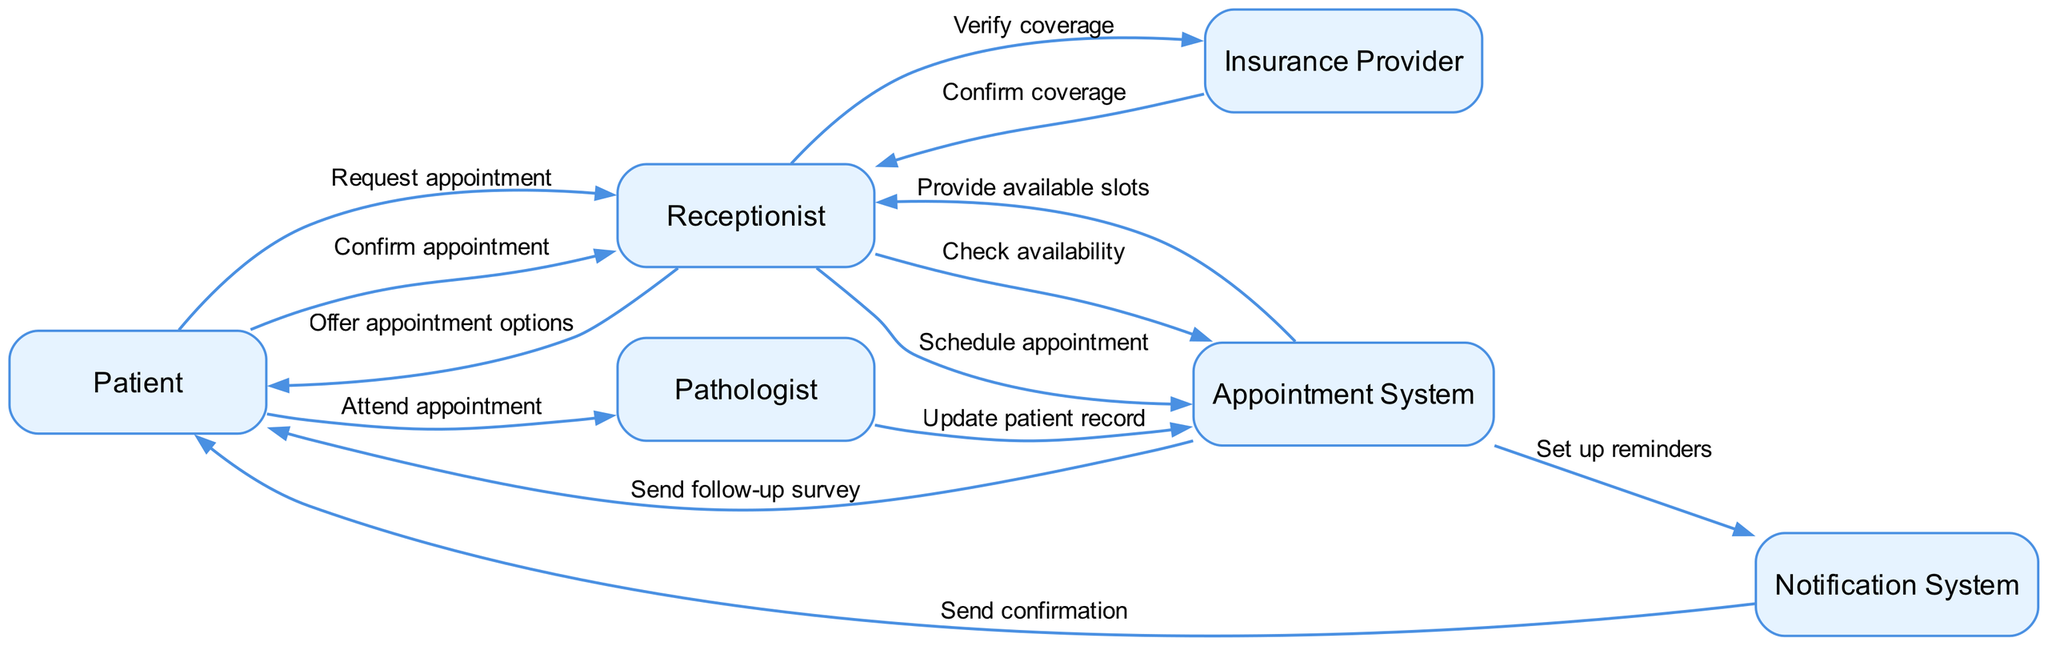What entities are involved in this sequence diagram? The entities involved are the Patient, Receptionist, Appointment System, Pathologist, Notification System, and Insurance Provider. You can find these listed in the diagram's elements that represent various participants in the appointment scheduling process.
Answer: Patient, Receptionist, Appointment System, Pathologist, Notification System, Insurance Provider How many interactions are depicted in the sequence diagram? By counting the edges (interactions) listed in the interactions section of the diagram, there are a total of 12 interactions shown.
Answer: 12 What does the Patient request from the Receptionist? The Patient requests an appointment from the Receptionist, which is the first interaction in the sequence. This indicates the starting point of the interaction flow.
Answer: Appointment Who verifies insurance coverage during the appointment scheduling process? The Receptionist interacts with the Insurance Provider to verify coverage, as indicated by the flow of information from the Receptionist to the Insurance Provider in the diagram.
Answer: Receptionist What action does the Notification System perform after setting up reminders? After setting up reminders, the Notification System sends a confirmation to the Patient, as shown in the interaction sequence that follows the notification setup.
Answer: Send confirmation What is the final step in the appointment process involving the Patient? The final step occurs when the Appointment System sends a follow-up survey to the Patient after the Patient's visit to the Pathologist. This indicates the conclusion of the appointment process in the diagram.
Answer: Send follow-up survey Which participant confirms coverage to the Receptionist? The Insurance Provider confirms coverage back to the Receptionist in response to the verification request, highlighting the interaction regarding insurance coverage.
Answer: Insurance Provider What is the role of the Appointment System in the diagram? The Appointment System manages the scheduling and tracking of patient appointments, providing available slots to the Receptionist and updating patient records after the appointment. This role is central to the interactions depicted.
Answer: Manage appointments 